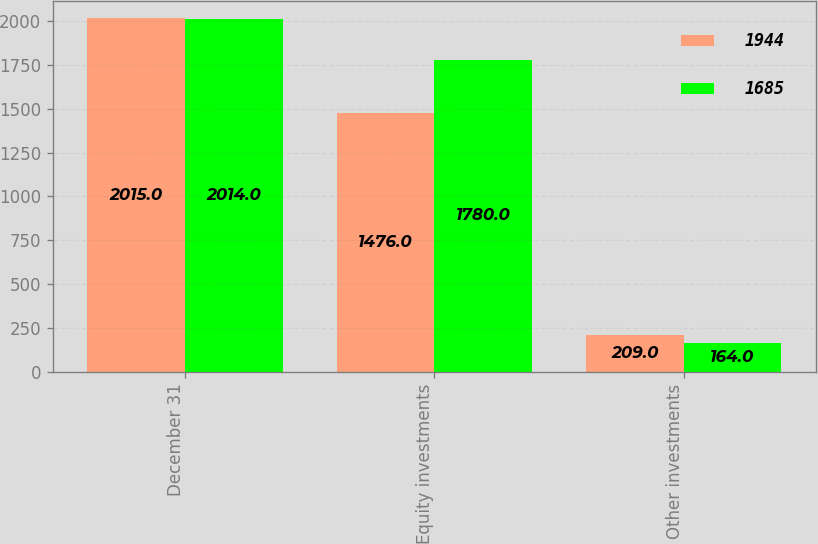Convert chart. <chart><loc_0><loc_0><loc_500><loc_500><stacked_bar_chart><ecel><fcel>December 31<fcel>Equity investments<fcel>Other investments<nl><fcel>1944<fcel>2015<fcel>1476<fcel>209<nl><fcel>1685<fcel>2014<fcel>1780<fcel>164<nl></chart> 